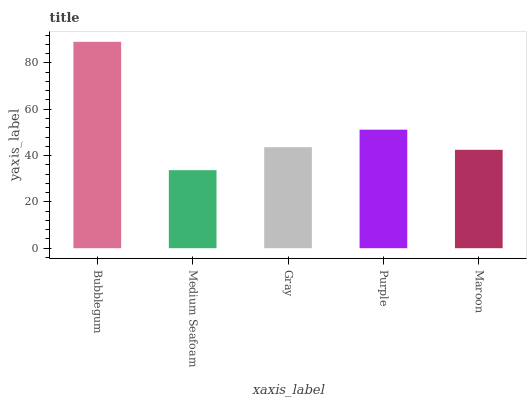Is Medium Seafoam the minimum?
Answer yes or no. Yes. Is Bubblegum the maximum?
Answer yes or no. Yes. Is Gray the minimum?
Answer yes or no. No. Is Gray the maximum?
Answer yes or no. No. Is Gray greater than Medium Seafoam?
Answer yes or no. Yes. Is Medium Seafoam less than Gray?
Answer yes or no. Yes. Is Medium Seafoam greater than Gray?
Answer yes or no. No. Is Gray less than Medium Seafoam?
Answer yes or no. No. Is Gray the high median?
Answer yes or no. Yes. Is Gray the low median?
Answer yes or no. Yes. Is Maroon the high median?
Answer yes or no. No. Is Medium Seafoam the low median?
Answer yes or no. No. 